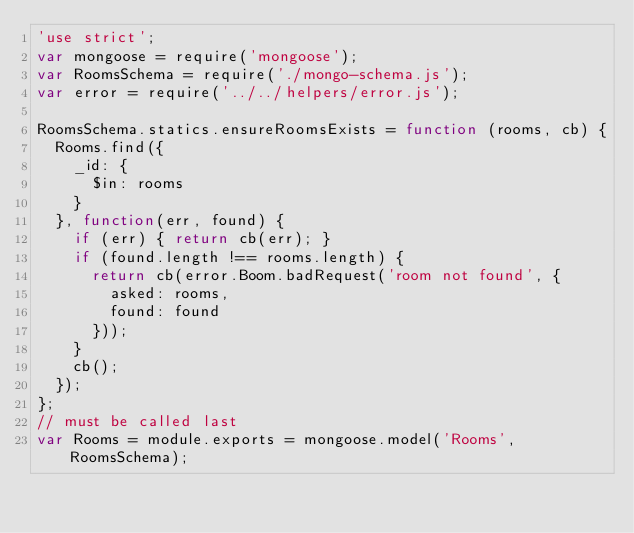<code> <loc_0><loc_0><loc_500><loc_500><_JavaScript_>'use strict';
var mongoose = require('mongoose');
var RoomsSchema = require('./mongo-schema.js');
var error = require('../../helpers/error.js');

RoomsSchema.statics.ensureRoomsExists = function (rooms, cb) {
  Rooms.find({
    _id: {
      $in: rooms
    }
  }, function(err, found) {
    if (err) { return cb(err); }
    if (found.length !== rooms.length) {
      return cb(error.Boom.badRequest('room not found', {
        asked: rooms,
        found: found
      }));
    }
    cb();
  });
};
// must be called last
var Rooms = module.exports = mongoose.model('Rooms', RoomsSchema);
</code> 